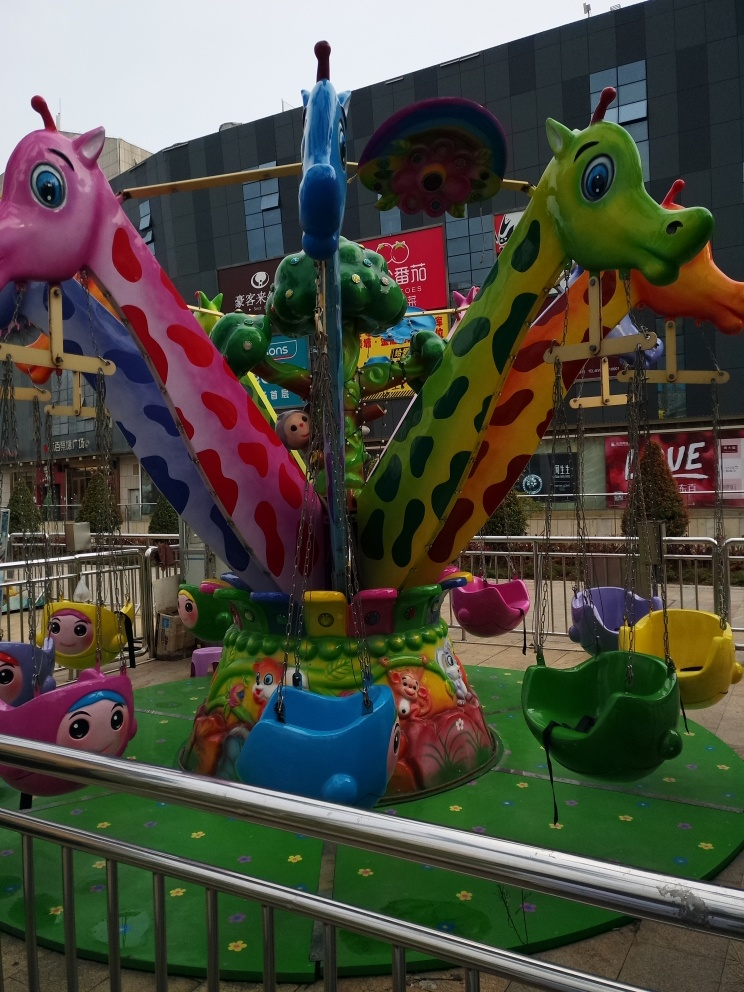Are there any focus issues in the image? The image appears to be properly focused, with clear details on the colorful carousel and its unique animal shapes visible in the foreground. The background elements, such as the mall and signs, while not as sharp due to depth of field, do not show signs of unintentional blurring that would indicate focus issues. 